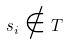<formula> <loc_0><loc_0><loc_500><loc_500>s _ { i } \notin T</formula> 